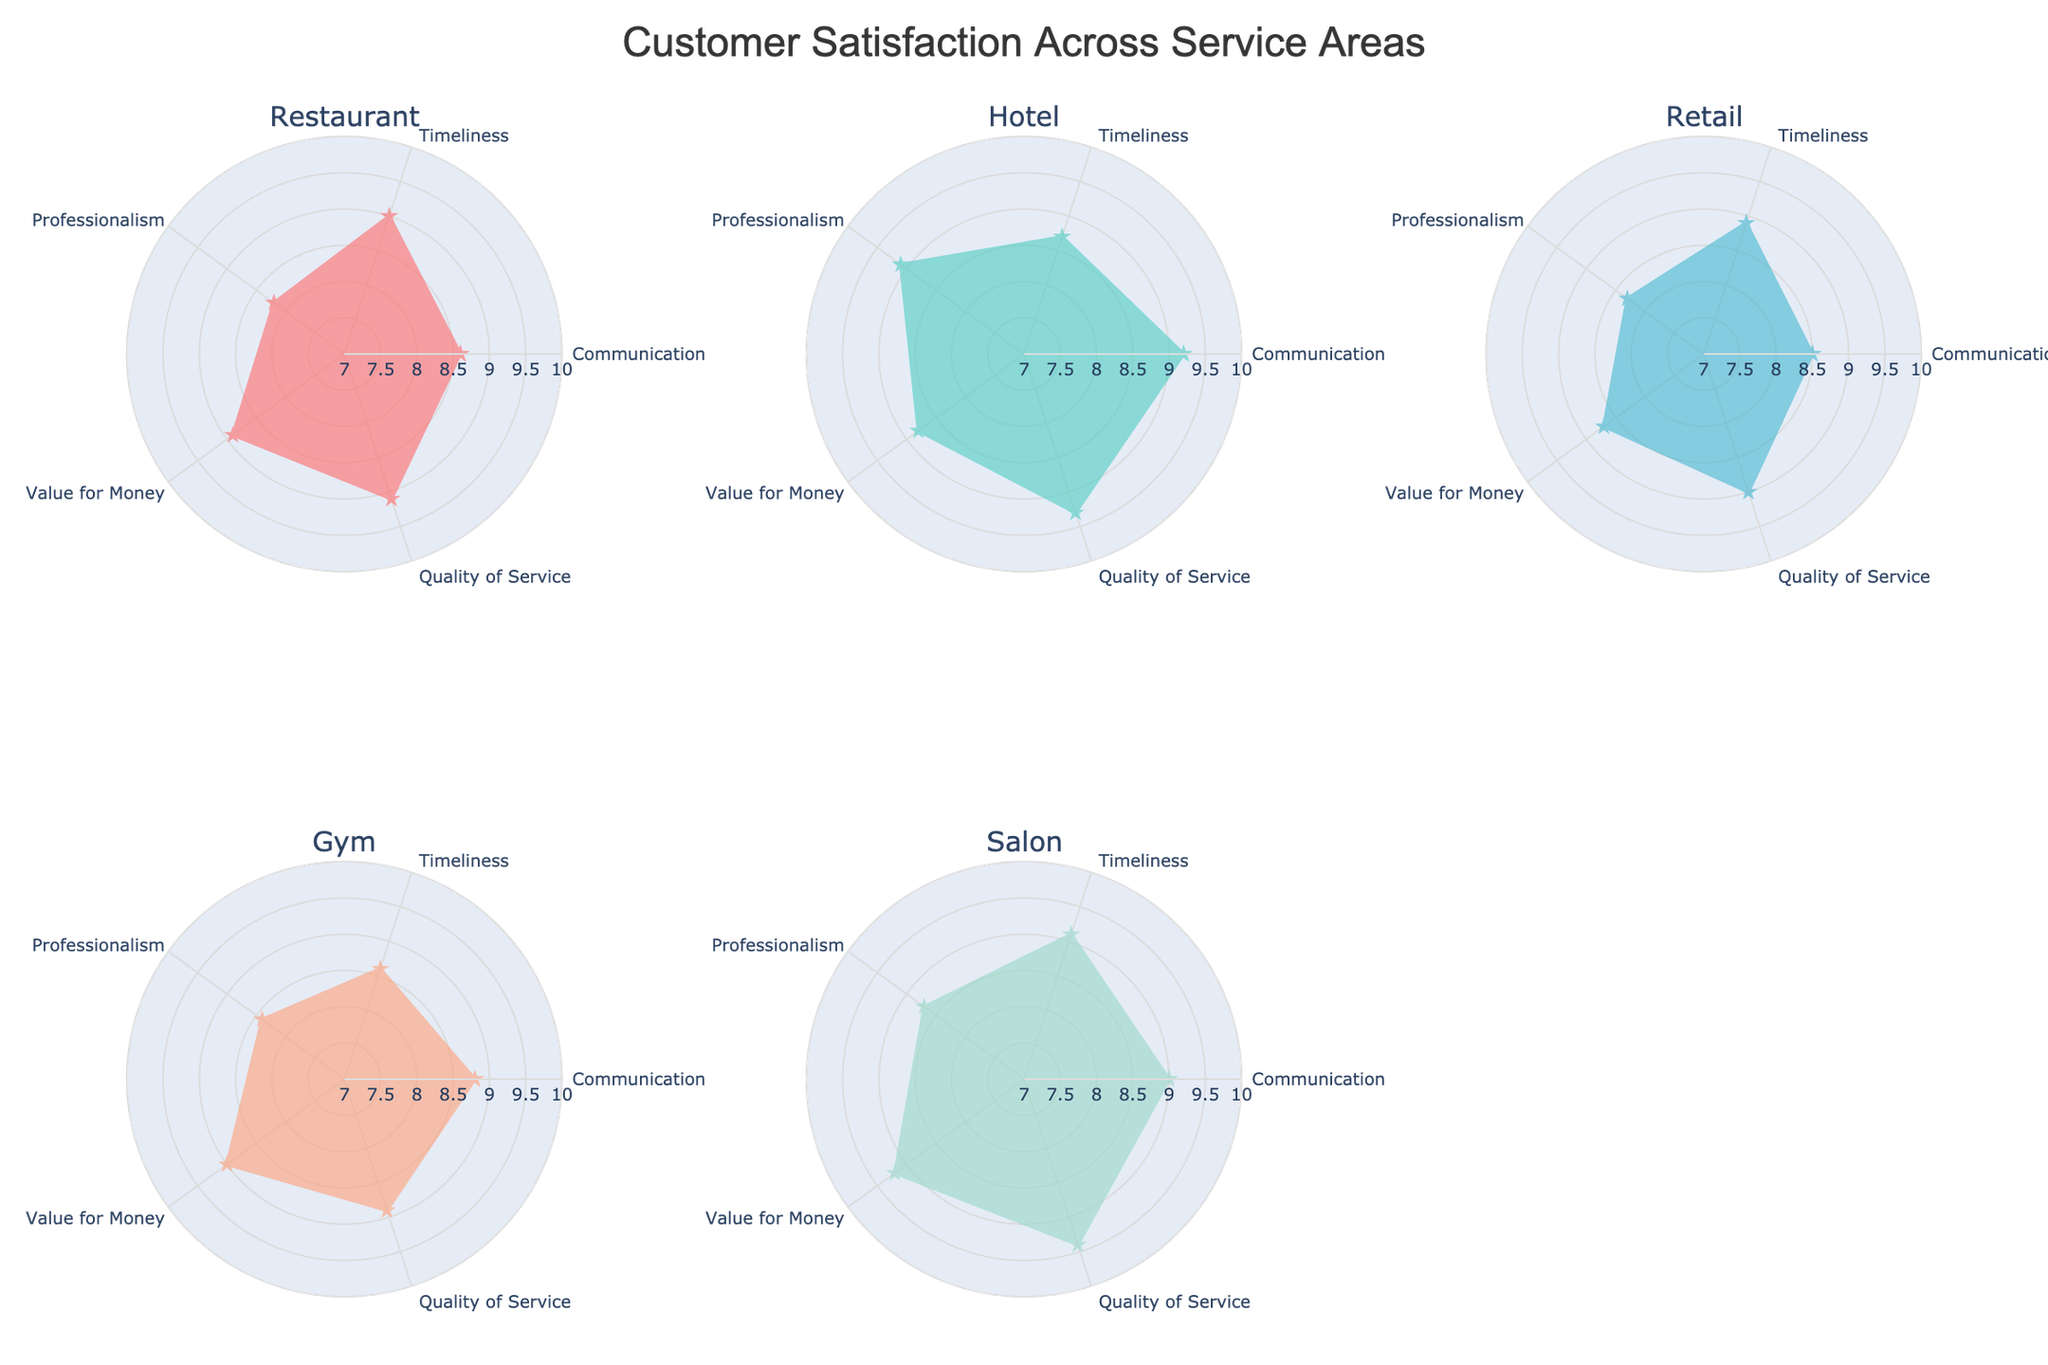What is the title of the figure? The title is always shown at the top center of the figure. For this radar chart, it is clearly written at the center and top of the chart.
Answer: Customer Satisfaction Across Service Areas How many service areas are compared in the radar charts? Check the number of subplot titles, each corresponding to a service area. In this case, there are five subplot titles.
Answer: 5 Which service area has the highest rating for Quality of Service? Look at the "Quality of Service" axis in each of the radar charts and identify the highest point. The Salon has a rating of 9.4, which is the highest.
Answer: Salon In which service area is Professionalism rated the lowest? Look at the "Professionalism" axis in each chart and find the lowest point. The Restaurant has the lowest rating of 8.2.
Answer: Restaurant What is the average rating for Timeliness across all service areas? Add up all the ratings for "Timeliness" and divide by the number of service areas: (8.2 + 9.1 + 8.3 + 8.4 + 8.7) / 5.
Answer: 8.54 Which service area has the most balanced ratings across all service attributes? Evaluate the congruity of each radar chart polygon. The polygons are most balanced for the Gym, which has fairly similar ratings in all areas.
Answer: Gym How does the rating of Communication for Salon compare to that for Hotel? Look at the "Communication" axis in both the Salon and Hotel radar charts. Salon is rated at 9.1, while Hotel is rated at 8.7. Salon has a higher rating.
Answer: Salon What is the difference in the rating of Value for Money between Gym and Retail? Look at the "Value for Money" axis for both Gym and Retail. Gym is rated 9.0, and Retail is rated 8.7. The difference is 9.0 - 8.7 = 0.3.
Answer: 0.3 Are there any service areas with the same rating for Professionalism? Check the "Professionalism" axis on each radar chart. Both Restaurant and Gym have the same rating at 8.4.
Answer: Restaurant and Gym 